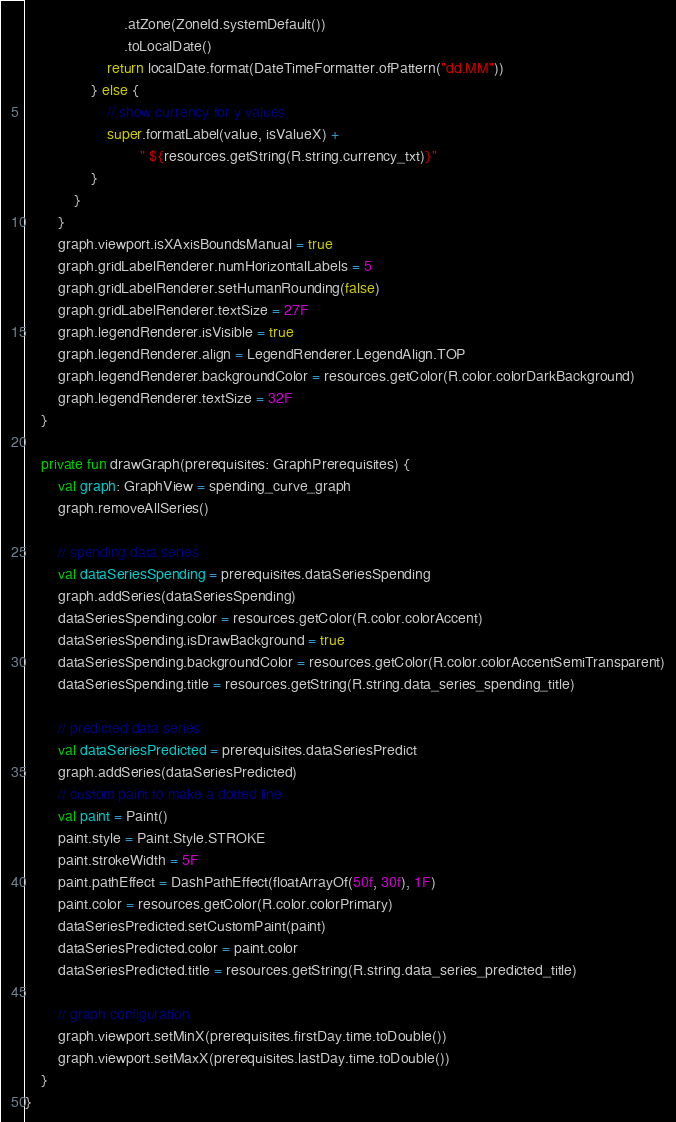<code> <loc_0><loc_0><loc_500><loc_500><_Kotlin_>                        .atZone(ZoneId.systemDefault())
                        .toLocalDate()
                    return localDate.format(DateTimeFormatter.ofPattern("dd.MM"))
                } else {
                    // show currency for y values
                    super.formatLabel(value, isValueX) +
                            " ${resources.getString(R.string.currency_txt)}"
                }
            }
        }
        graph.viewport.isXAxisBoundsManual = true
        graph.gridLabelRenderer.numHorizontalLabels = 5
        graph.gridLabelRenderer.setHumanRounding(false)
        graph.gridLabelRenderer.textSize = 27F
        graph.legendRenderer.isVisible = true
        graph.legendRenderer.align = LegendRenderer.LegendAlign.TOP
        graph.legendRenderer.backgroundColor = resources.getColor(R.color.colorDarkBackground)
        graph.legendRenderer.textSize = 32F
    }

    private fun drawGraph(prerequisites: GraphPrerequisites) {
        val graph: GraphView = spending_curve_graph
        graph.removeAllSeries()

        // spending data series
        val dataSeriesSpending = prerequisites.dataSeriesSpending
        graph.addSeries(dataSeriesSpending)
        dataSeriesSpending.color = resources.getColor(R.color.colorAccent)
        dataSeriesSpending.isDrawBackground = true
        dataSeriesSpending.backgroundColor = resources.getColor(R.color.colorAccentSemiTransparent)
        dataSeriesSpending.title = resources.getString(R.string.data_series_spending_title)

        // predicted data series
        val dataSeriesPredicted = prerequisites.dataSeriesPredict
        graph.addSeries(dataSeriesPredicted)
        // custom paint to make a dotted line
        val paint = Paint()
        paint.style = Paint.Style.STROKE
        paint.strokeWidth = 5F
        paint.pathEffect = DashPathEffect(floatArrayOf(50f, 30f), 1F)
        paint.color = resources.getColor(R.color.colorPrimary)
        dataSeriesPredicted.setCustomPaint(paint)
        dataSeriesPredicted.color = paint.color
        dataSeriesPredicted.title = resources.getString(R.string.data_series_predicted_title)

        // graph configuration
        graph.viewport.setMinX(prerequisites.firstDay.time.toDouble())
        graph.viewport.setMaxX(prerequisites.lastDay.time.toDouble())
    }
}
</code> 